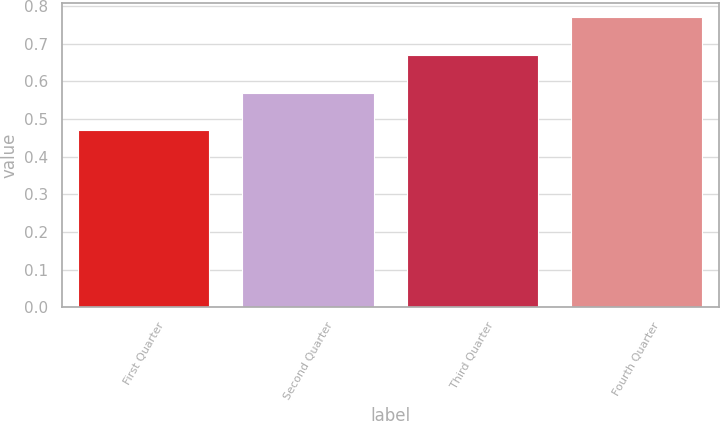<chart> <loc_0><loc_0><loc_500><loc_500><bar_chart><fcel>First Quarter<fcel>Second Quarter<fcel>Third Quarter<fcel>Fourth Quarter<nl><fcel>0.47<fcel>0.57<fcel>0.67<fcel>0.77<nl></chart> 